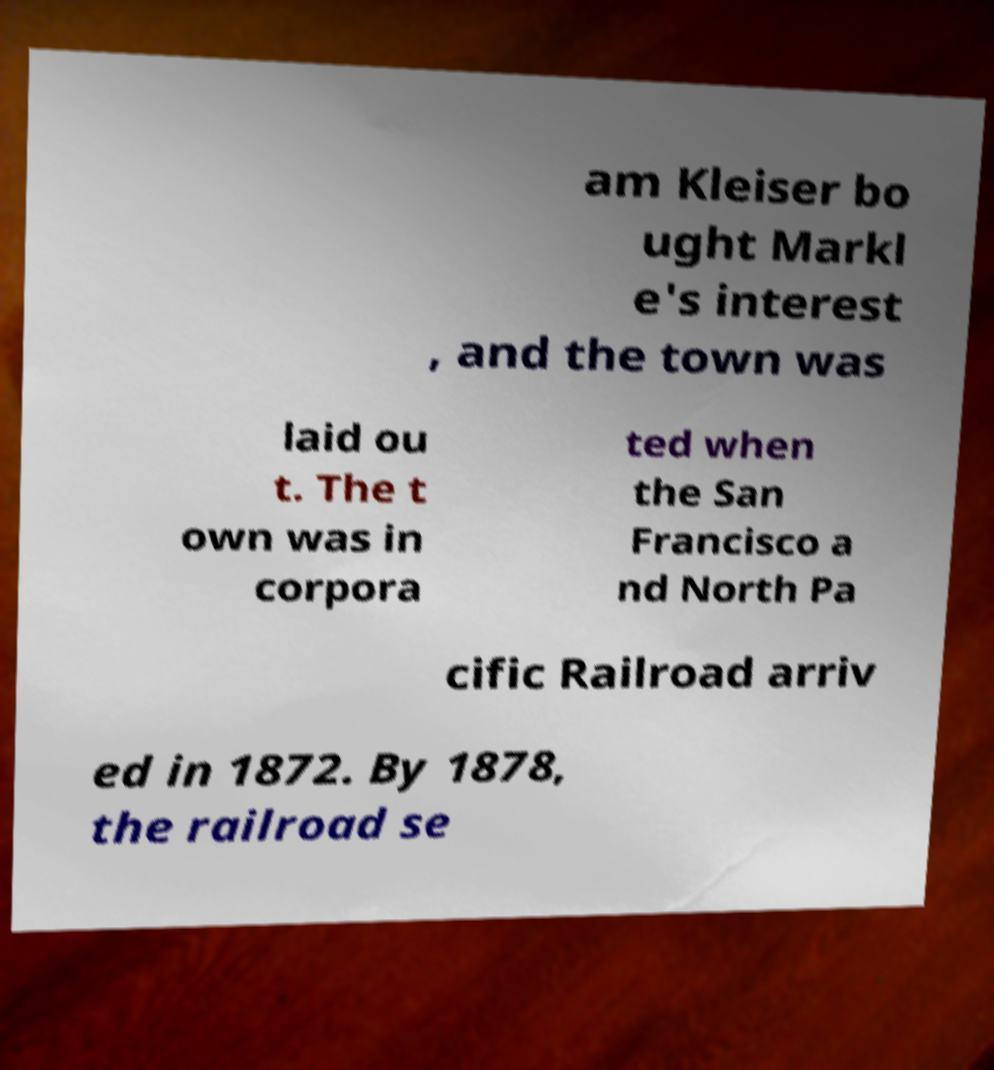Please identify and transcribe the text found in this image. am Kleiser bo ught Markl e's interest , and the town was laid ou t. The t own was in corpora ted when the San Francisco a nd North Pa cific Railroad arriv ed in 1872. By 1878, the railroad se 